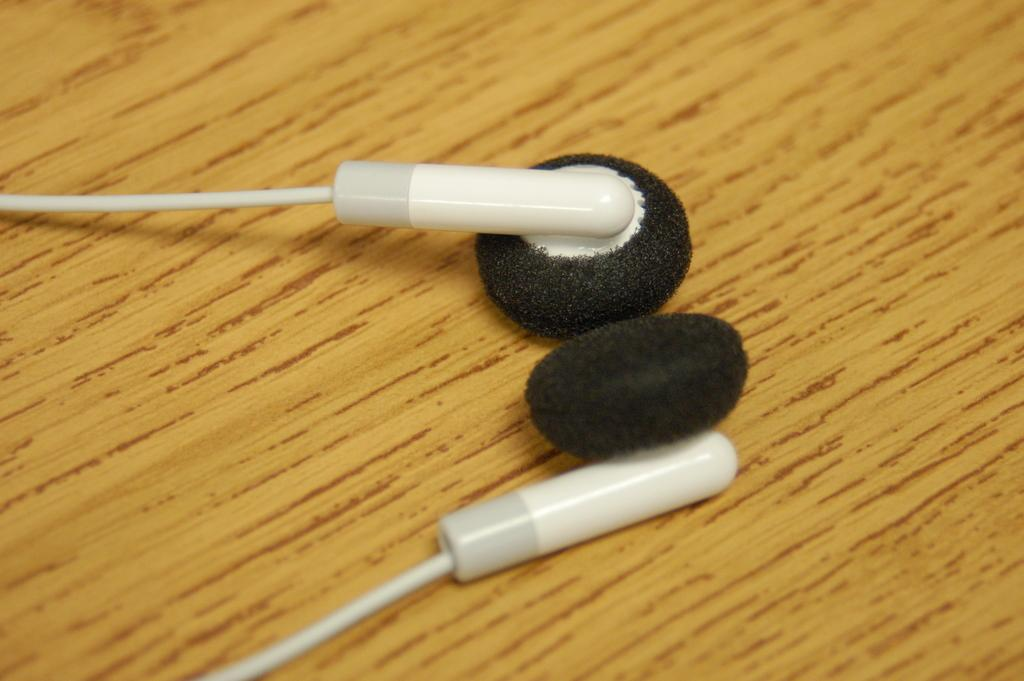What is the main object in the image? There is a pair of earphones in the image. Where are the earphones placed? The earphones are placed on a wooden surface. What type of jar is visible in the image? There is no jar present in the image; it only features a pair of earphones placed on a wooden surface. 